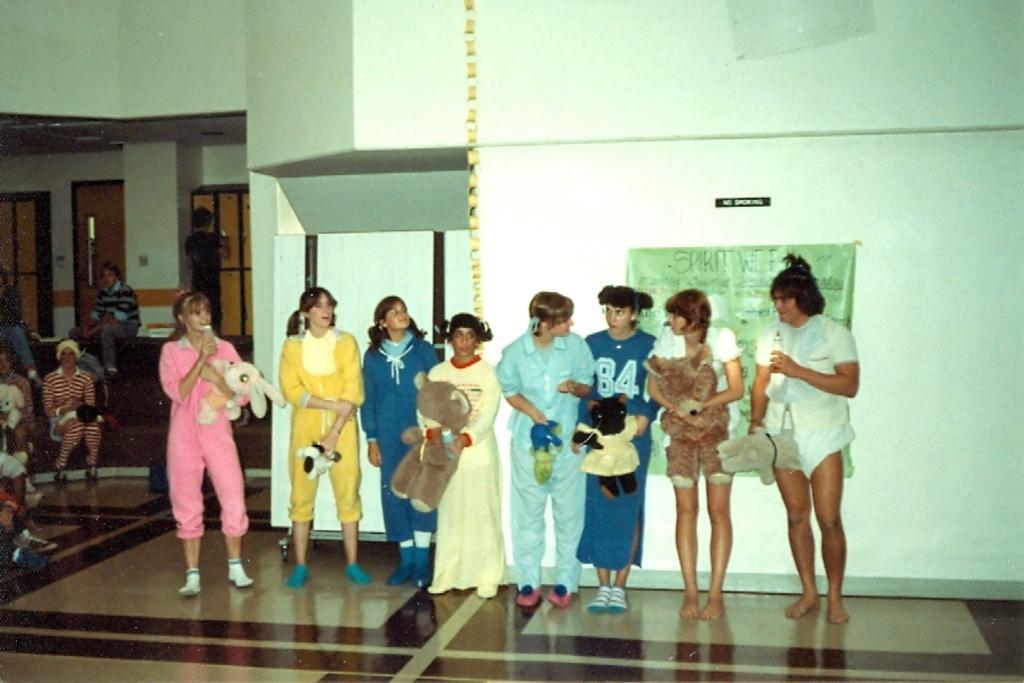Can you describe this image briefly? In this image I can see a group of girls are standing by holding the dolls in their hands behind them there is a banner to the wall. 